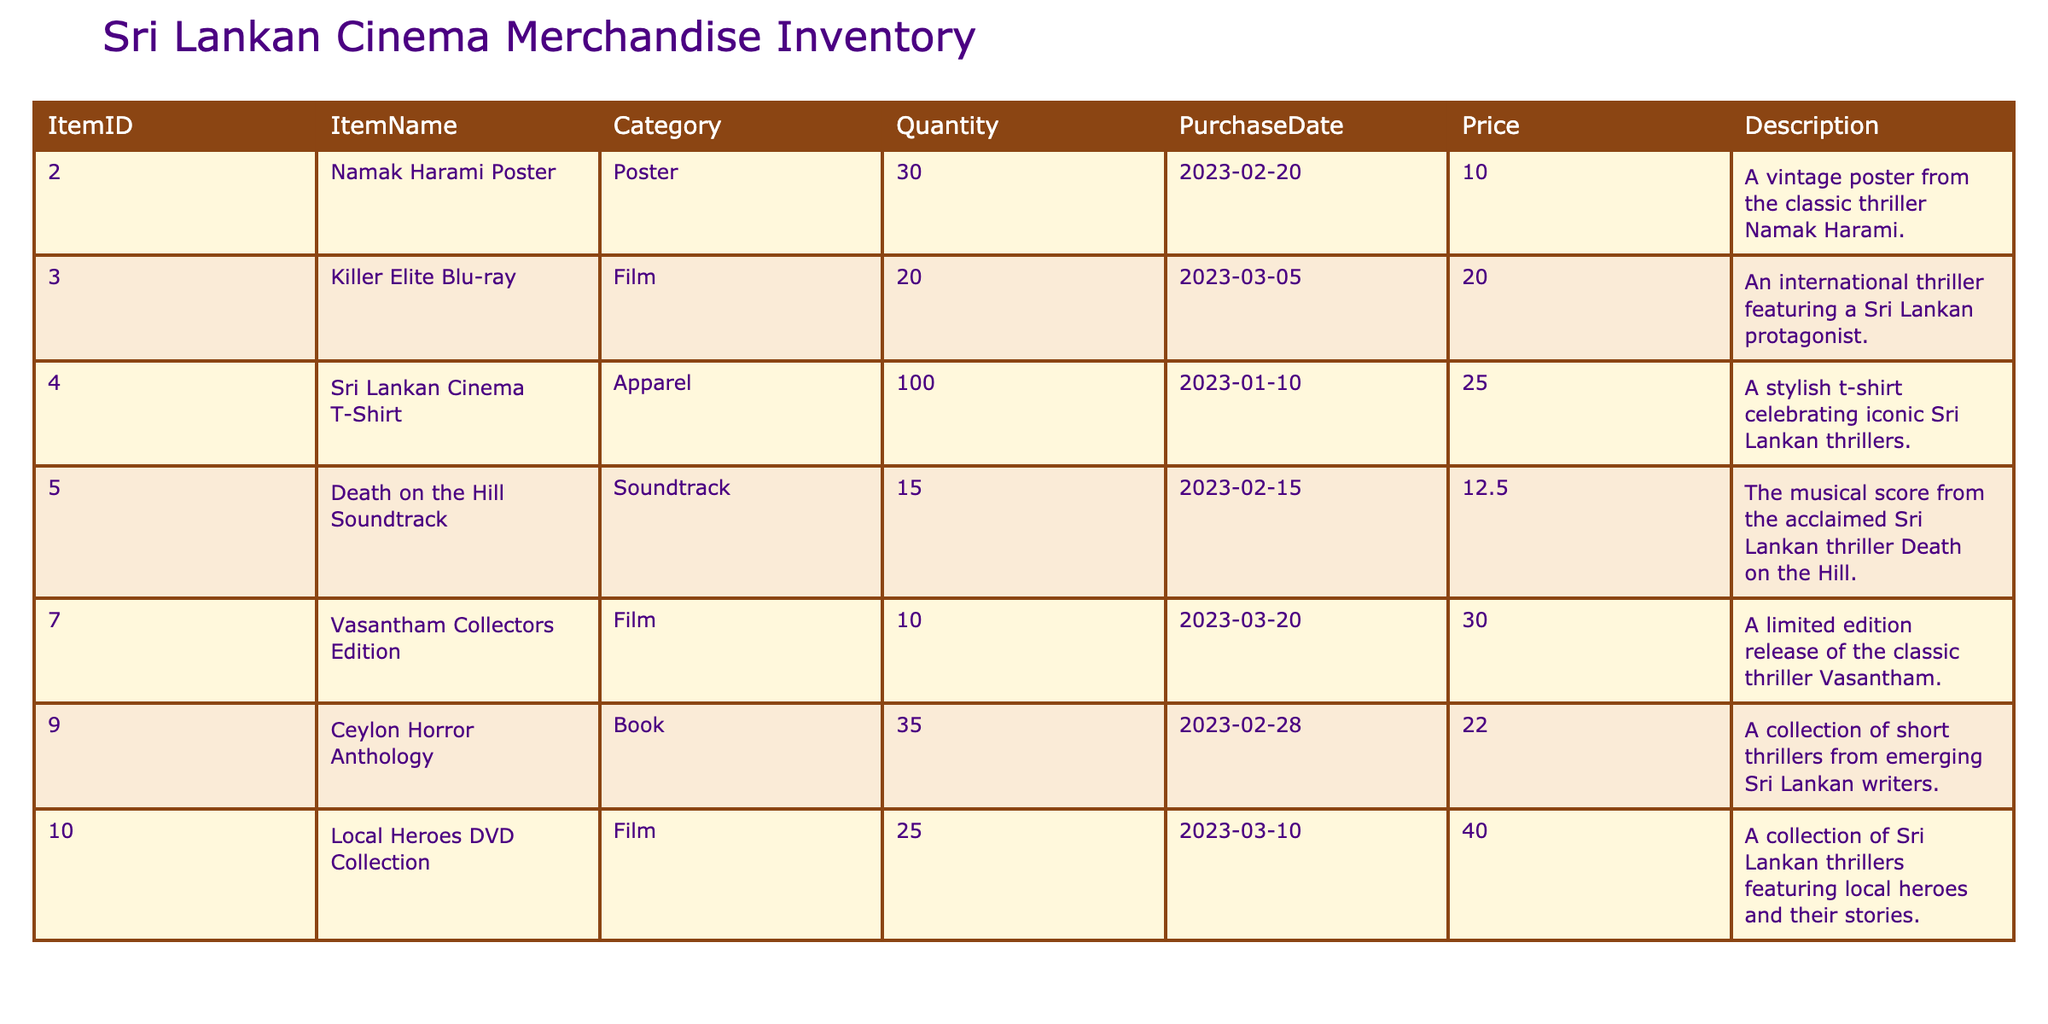What is the item name for ItemID 4? The table indicates that ItemID 4 corresponds to the item "Death on the Hill Soundtrack."
Answer: Death on the Hill Soundtrack How many apparel items are in the inventory? According to the table, there is only one apparel item listed, which is "Sri Lankan Cinema T-Shirt" with a quantity of 100.
Answer: 100 What is the total quantity of films available? The films in the inventory include "Killer Elite Blu-ray" (20), "Vasantham Collectors Edition" (10), and "Local Heroes DVD Collection" (25). Summing these gives (20 + 10 + 25) = 55 films in total.
Answer: 55 Is there any item in the inventory that costs more than 30.00? By reviewing the pricing information in the table, the "Vasantham Collectors Edition" costs 30.00, and the "Local Heroes DVD Collection" costs 40.00; therefore, there are items priced higher than 30.00.
Answer: Yes What is the average price of all the items listed? The prices are 10.00, 20.00, 25.00, 12.50, 30.00, 22.00, and 40.00. Adding these gives a total of 129.50, and since there are 7 items, the average price is 129.50/7 = approximately 18.50.
Answer: 18.50 How many posters are in stock compared to soundtracks? From the table, there are 30 "Namak Harami Posters" and 15 "Death on the Hill Soundtracks." Comparing them, there are more posters than soundtracks, specifically (30 - 15) = 15 more posters.
Answer: 15 more posters Which item has the lowest quantity? By examining the quantities in the table, "Vasantham Collectors Edition" has the lowest quantity with only 10 units in stock.
Answer: Vasantham Collectors Edition Is the "Ceylon Horror Anthology" a film or a book? The "Ceylon Horror Anthology" is categorized as a book according to the inventory table.
Answer: Book 